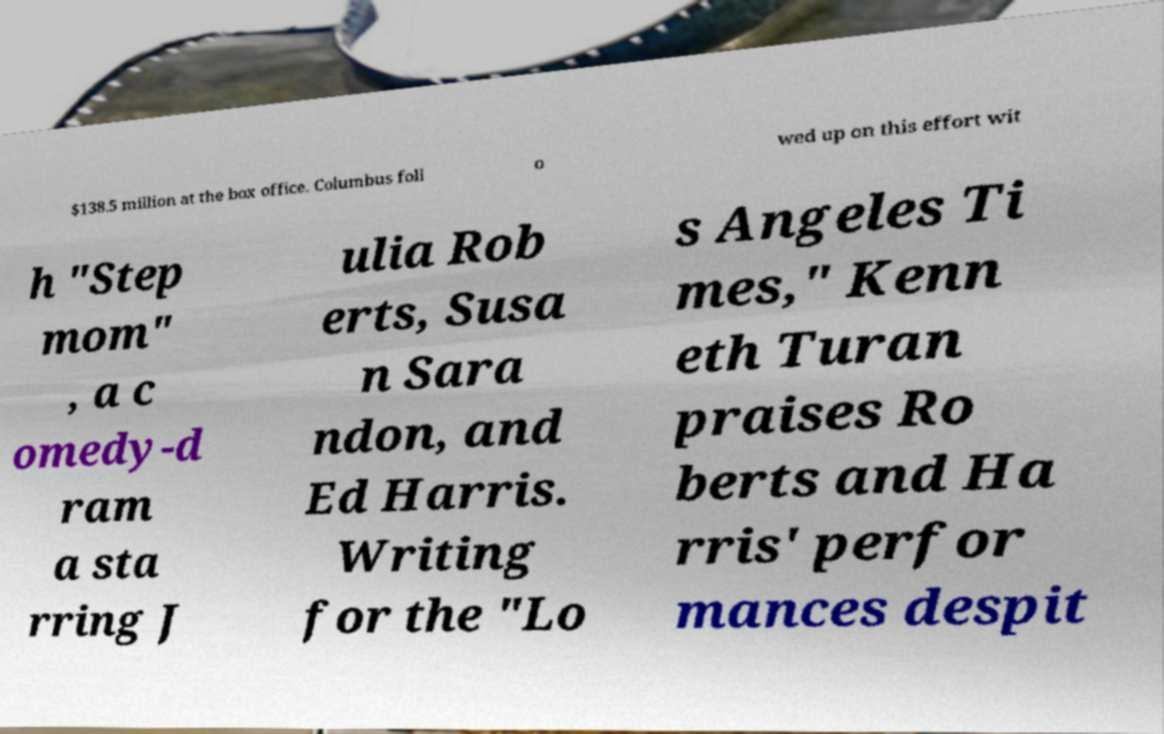What messages or text are displayed in this image? I need them in a readable, typed format. $138.5 million at the box office. Columbus foll o wed up on this effort wit h "Step mom" , a c omedy-d ram a sta rring J ulia Rob erts, Susa n Sara ndon, and Ed Harris. Writing for the "Lo s Angeles Ti mes," Kenn eth Turan praises Ro berts and Ha rris' perfor mances despit 